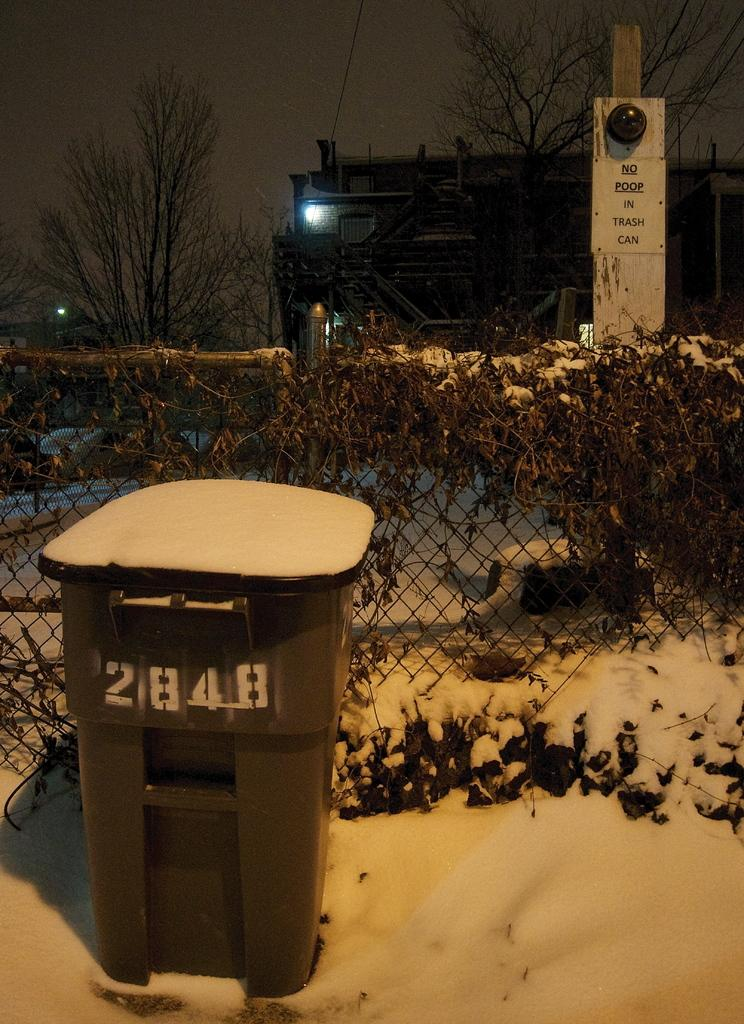<image>
Write a terse but informative summary of the picture. a snow covered trash can sitting by a fence is numbered 2848 